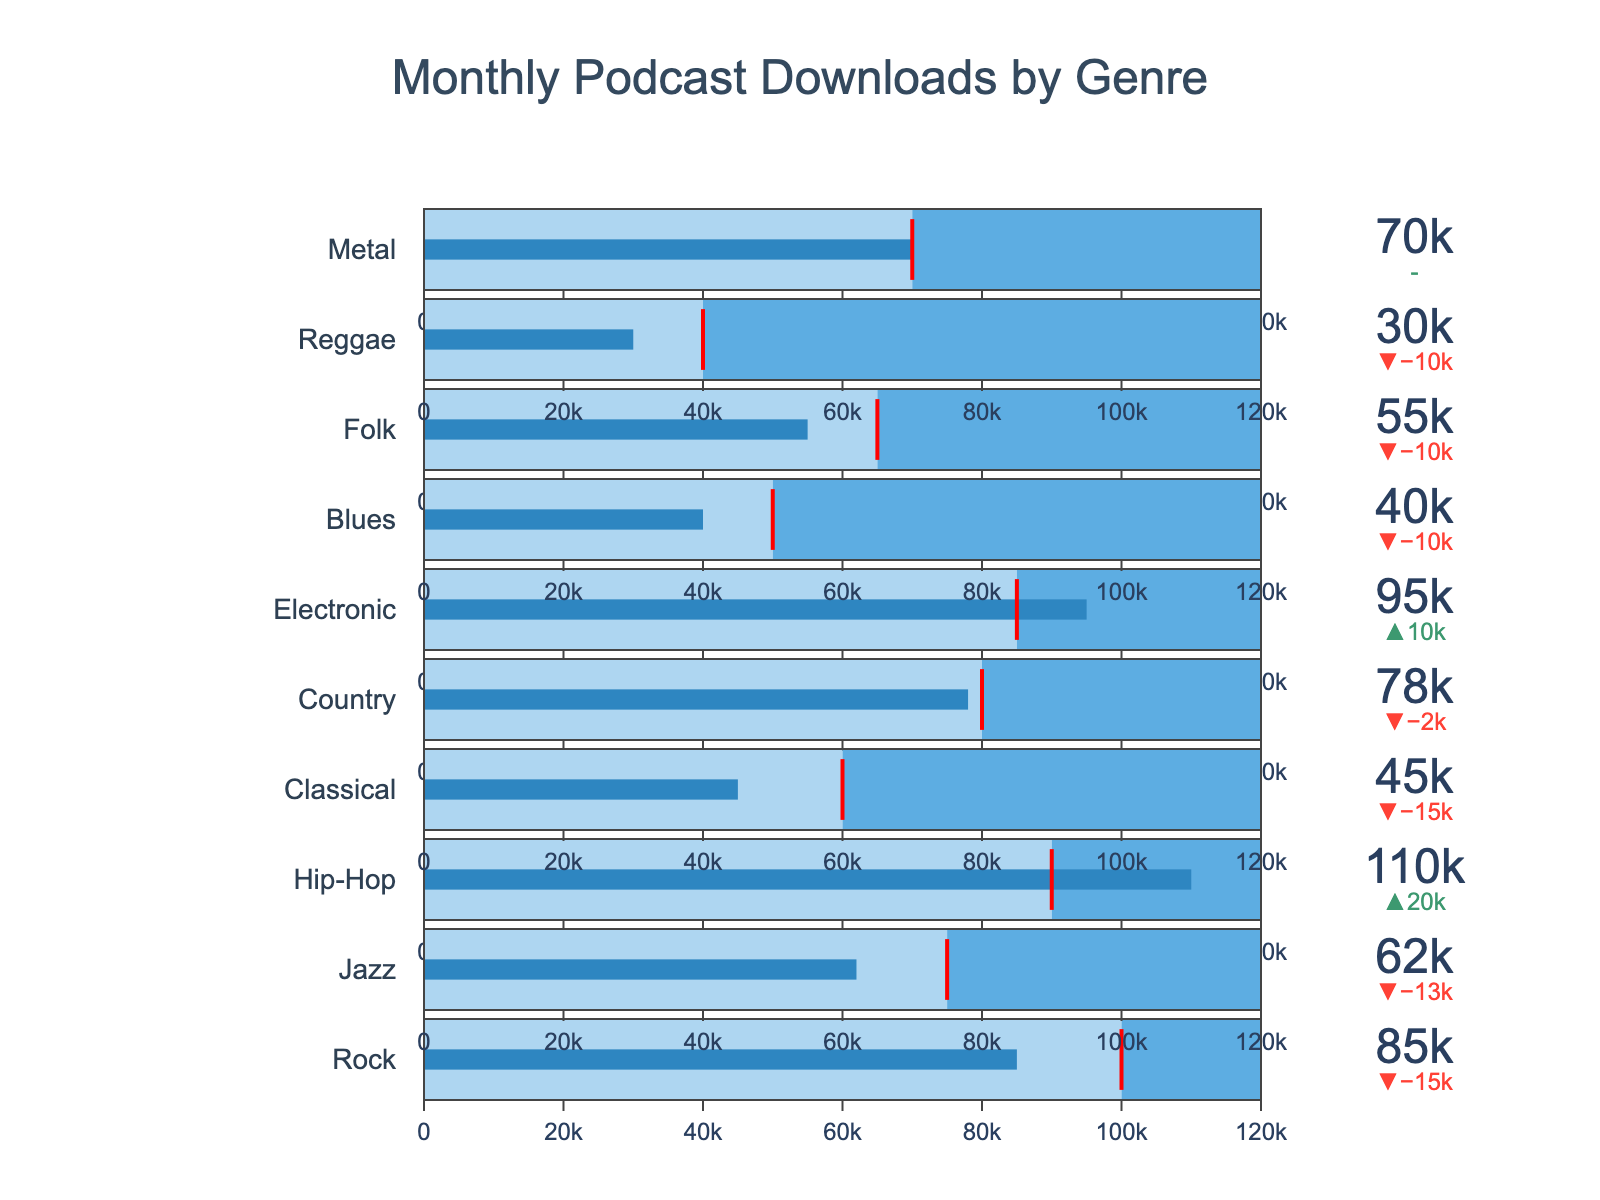What's the title of the chart? The title is usually found at the top of the chart. In this case, the chart title is "Monthly Podcast Downloads by Genre."
Answer: Monthly Podcast Downloads by Genre How many genres have their actual downloads below their target? To answer this, count the number of genres where the actual value is less than the target value. Genres with downloads below their targets are Rock, Jazz, Classical, Country, Blues, Folk, and Reggae.
Answer: 7 Which genre has the highest number of actual downloads and how does it compare to its target? Look for the highest "Actual" value and compare it to its "Target." The genre with the highest actual downloads is Hip-Hop with 110,000 downloads compared to its target of 90,000.
Answer: Hip-Hop; 20,000 above target Which genre exactly met its target downloads? Look for a genre where the "Actual" value equals the "Target" value. The only genre that meets this criterion is Metal.
Answer: Metal What's the total number of downloads for Country and Blues genres combined? Add the actual download values of Country and Blues. Country has 78,000 and Blues has 40,000 downloads, so the total is 78,000 + 40,000 = 118,000.
Answer: 118,000 How much did Electronic surpass its target by? Subtract the target value of Electronic from its actual value. Electronic has 95,000 actual downloads and a target of 85,000, so it surpassed its target by 95,000 - 85,000 = 10,000.
Answer: 10,000 Which two genres have actual downloads closest to their targets? To find this, look for the smallest difference between the actual and target downloads. Metal has 70,000/70,000 (exactly on target), and Country has 78,000/80,000 (a difference of 2,000), making them the closest.
Answer: Metal and Country What is the difference between the highest and lowest actual downloads across all genres? Subtract the lowest actual value from the highest actual value. The highest is 110,000 (Hip-Hop), and the lowest is 30,000 (Reggae), so the difference is 110,000 - 30,000 = 80,000.
Answer: 80,000 How many genres exceeded their target downloads by more than 10,000? Check each genre where the actual value exceeds the target by more than 10,000. Hip-Hop (20,000), Electronic (10,000), are such cases.
Answer: 2 What is the average target download goal across all genres? Sum all the target values and divide by the number of genres. The sum is 100,000 + 75,000 + 90,000 + 60,000 + 80,000 + 85,000 + 50,000 + 65,000 + 40,000 + 70,000 = 715,000. There are 10 genres, so the average is 715,000 / 10 = 71,500.
Answer: 71,500 